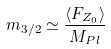<formula> <loc_0><loc_0><loc_500><loc_500>m _ { 3 / 2 } \simeq \frac { \langle F _ { Z _ { 0 } } \rangle } { M _ { P l } }</formula> 